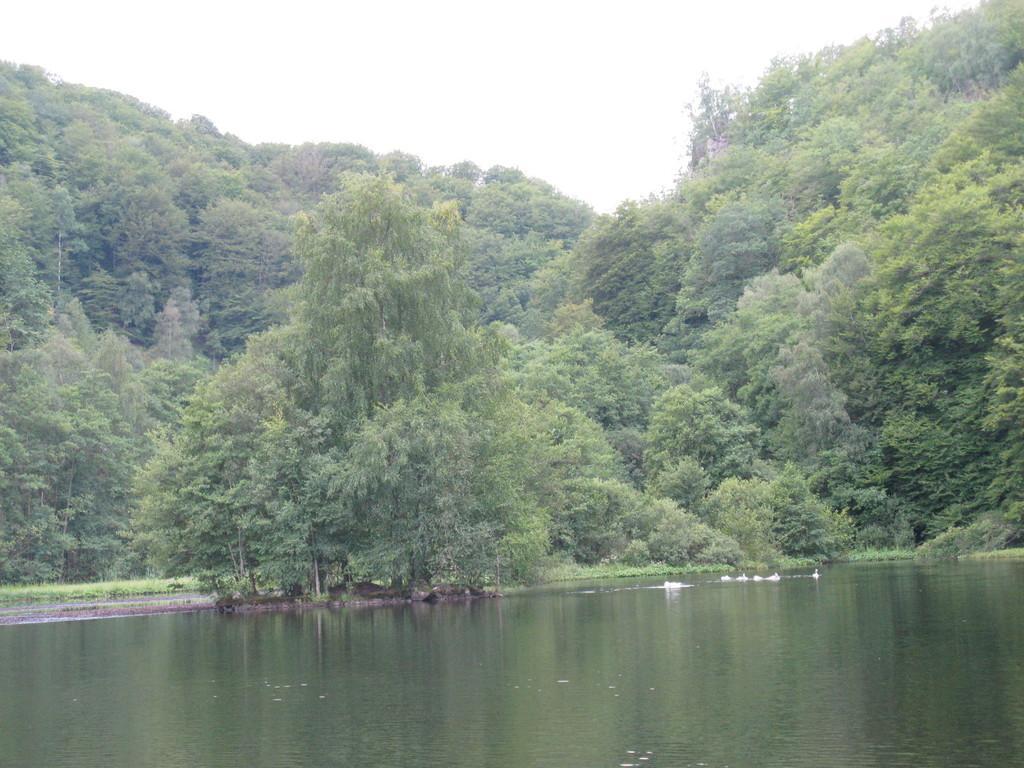Could you give a brief overview of what you see in this image? In this image I can see few green color trees and the water. The sky is in white color. 